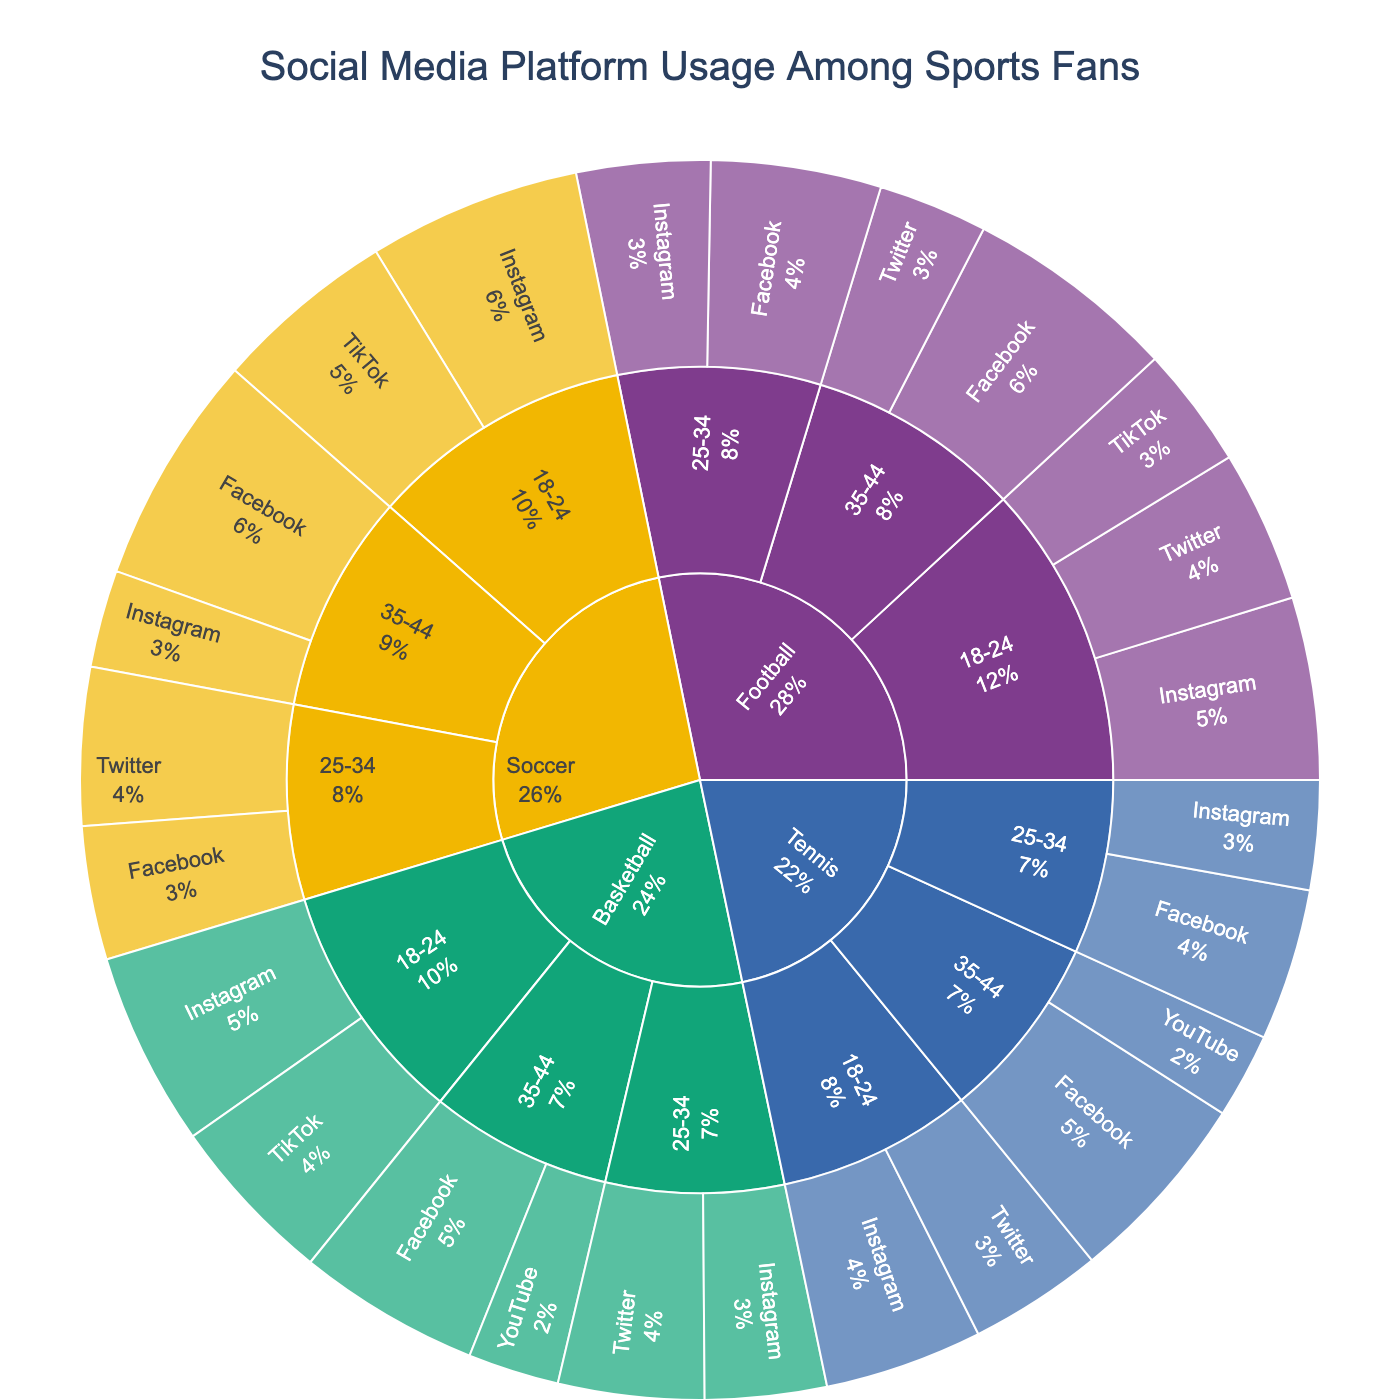What's the most popular social media platform for the 18-24 age group in Soccer? Find the segment corresponding to Soccer -> 18-24 -> Platform. The segment with the highest percentage is Instagram, which is recorded as 35%.
Answer: Instagram Which sport has the highest percentage of Facebook users in the 35-44 age group? Navigate to each sport and check the 35-44 age group segment, then find the platform Facebook. Soccer has the highest percentage at 38%.
Answer: Soccer What is the combined percentage of Instagram usage among 18-24-year-olds for all sports? Sum the percentages of Instagram usage for 18-24-year-olds across all sports: Football (30%) + Basketball (32%) + Tennis (26%) + Soccer (35%) = 123%.
Answer: 123% How does TikTok usage in the 18-24 age group for Basketball compare to Soccer? Locate the segments for Basketball -> 18-24 -> TikTok and Soccer -> 18-24 -> TikTok. Basketball has 28%, while Soccer has 30%. Therefore, Soccer has a higher percentage.
Answer: Soccer has higher TikTok usage What percentage of Twitter users are there among 25-34-year-olds in Football? Navigate to Football -> 25-34 -> Twitter. The percentage is recorded as 25%.
Answer: 25% Which age group uses Facebook the most across all sports? Identify the Facebook segments across all three age groups for each sport and compare the percentages. The 35-44 age group in Soccer has the highest percentage at 38%.
Answer: 35-44 in Soccer What is the average Instagram usage percentage in the 25-34 age group for all sports? Sum the Instagram percentages for the 25-34 age group across all sports and divide by the number of sports: (22% + 20% + 18%) / 3 = 20%.
Answer: 20% In Tennis, which platform is used the least by the 35-44 age group? Locate Tennis -> 35-44 and compare the platforms and their percentages. YouTube has the lowest usage at 14%.
Answer: YouTube How does Twitter usage compare between 18-24-year-olds in Football and 35-44-year-olds in Football? Find the segments for both age groups in Football. Twitter usage is 25% in 18-24 and 18% in 35-44. The 18-24 age group has higher usage.
Answer: 18-24 age group What's the combined percentage of Facebook users in the 25-34 age group for Tennis and Soccer? Check the Facebook segments for the 25-34 age group in Tennis and Soccer, then sum the percentages: 25% + 22% = 47%.
Answer: 47% 